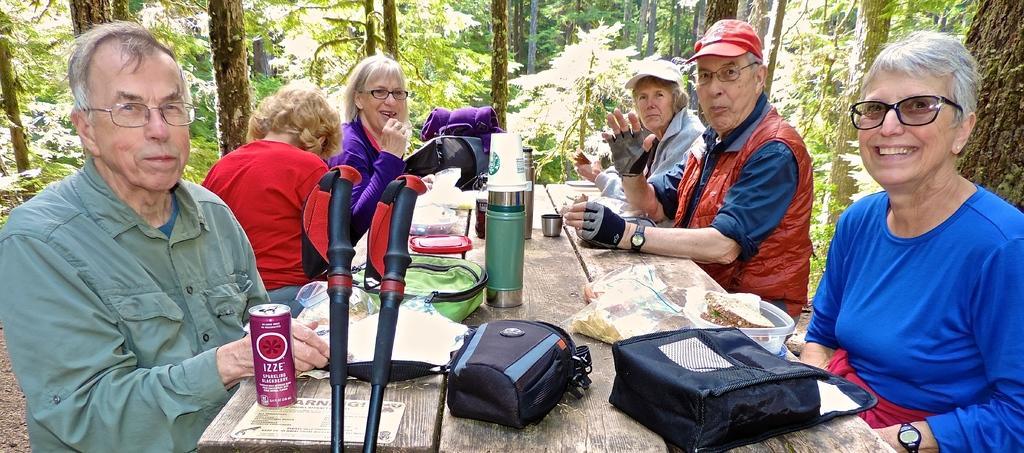How would you summarize this image in a sentence or two? There are six people sitting on the bench. This is the table with flasks, bags, boxes, tin and few other things on it. These are the trees with branches and leaves. I think these are the trekking sticks. 